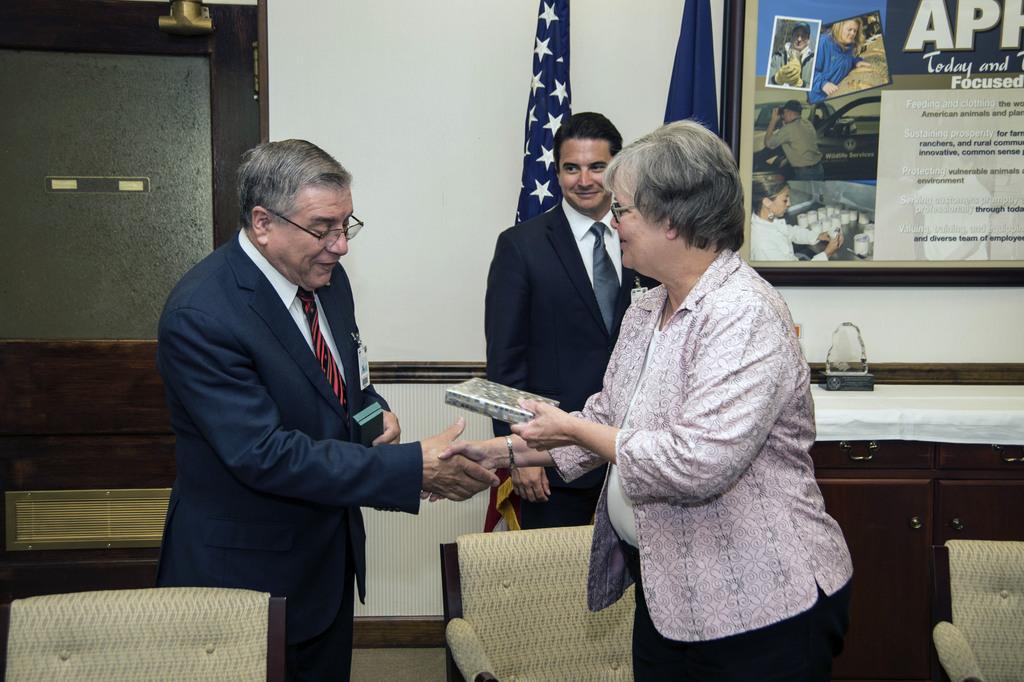Could you give a brief overview of what you see in this image? This is an inside view of a room. Here I can see a man and a woman are standing, shaking their hands and smiling. The woman is holding a box in her hand. At the bottom there are three chairs. At the back of these people a man is standing and smiling by looking at this man. On the right side there is a table which is covered with a cloth. In the background there is a door to the wall and also there are two flags. In the top right-hand corner there is a frame attached to the wall. On the frame, I can see some text and few images of persons. 